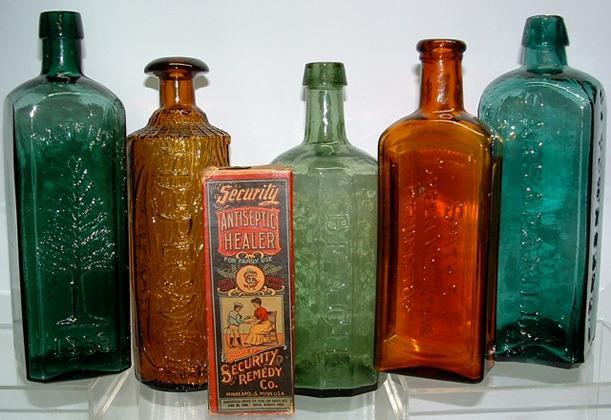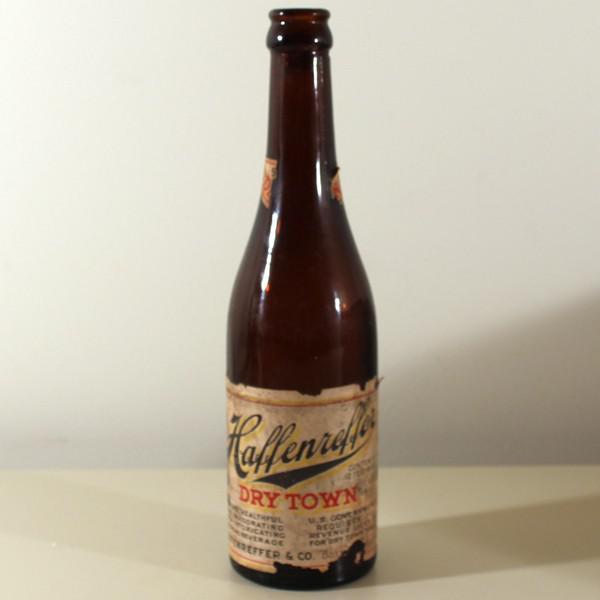The first image is the image on the left, the second image is the image on the right. Given the left and right images, does the statement "The left image contains three or more different bottles while the right image contains only a single bottle." hold true? Answer yes or no. Yes. The first image is the image on the left, the second image is the image on the right. Given the left and right images, does the statement "Two cobalt blue bottles are sitting among at least 18 other colorful bottles." hold true? Answer yes or no. No. 